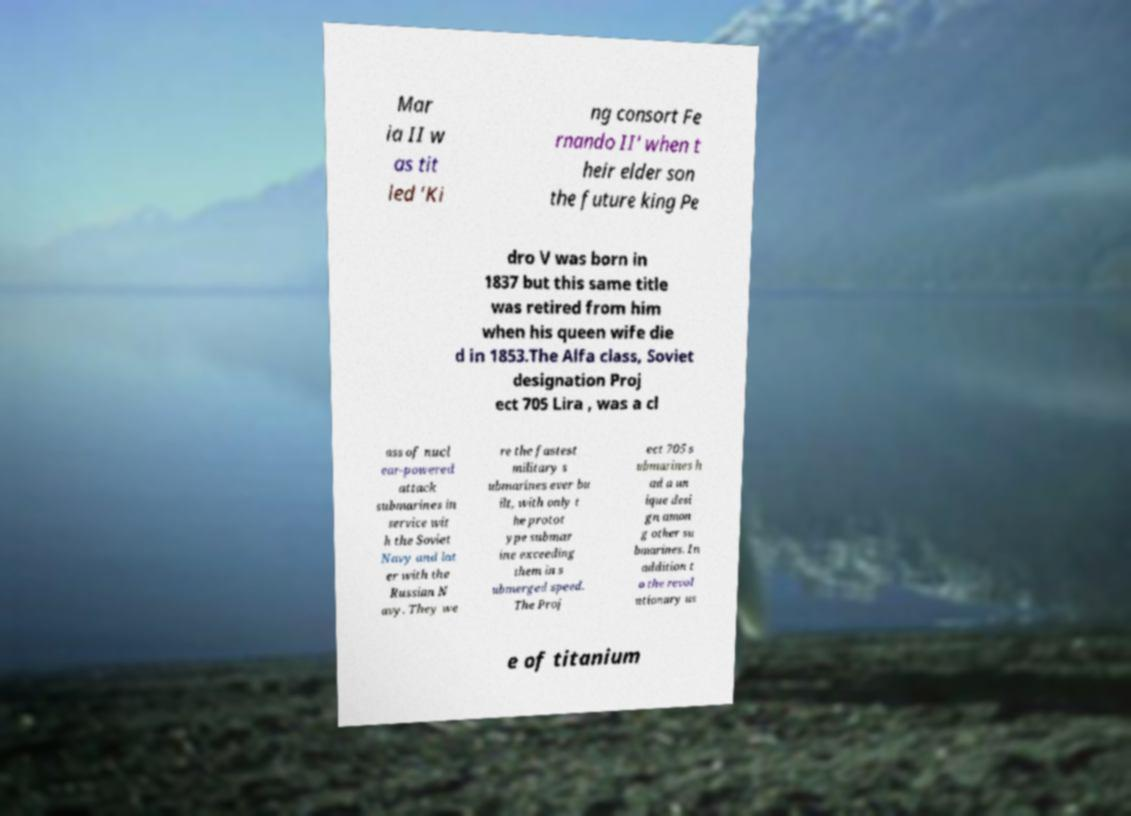There's text embedded in this image that I need extracted. Can you transcribe it verbatim? Mar ia II w as tit led 'Ki ng consort Fe rnando II' when t heir elder son the future king Pe dro V was born in 1837 but this same title was retired from him when his queen wife die d in 1853.The Alfa class, Soviet designation Proj ect 705 Lira , was a cl ass of nucl ear-powered attack submarines in service wit h the Soviet Navy and lat er with the Russian N avy. They we re the fastest military s ubmarines ever bu ilt, with only t he protot ype submar ine exceeding them in s ubmerged speed. The Proj ect 705 s ubmarines h ad a un ique desi gn amon g other su bmarines. In addition t o the revol utionary us e of titanium 